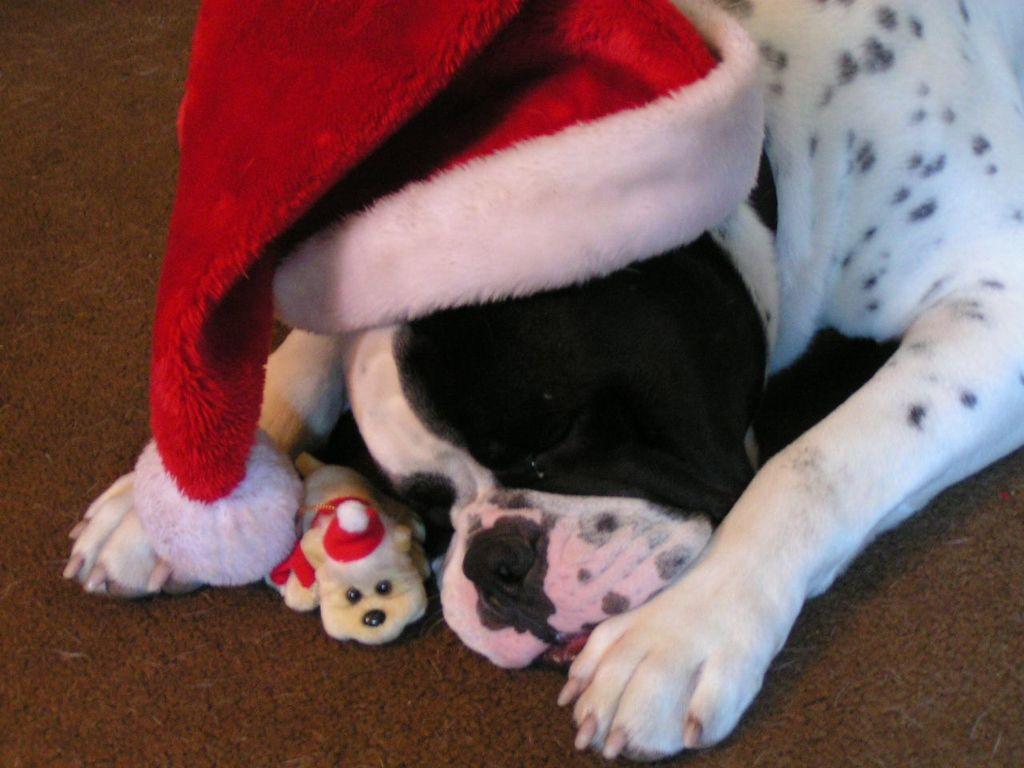Describe this image in one or two sentences. In this image, I can see a dog with a christmas hat and there is a toy on the floor. 